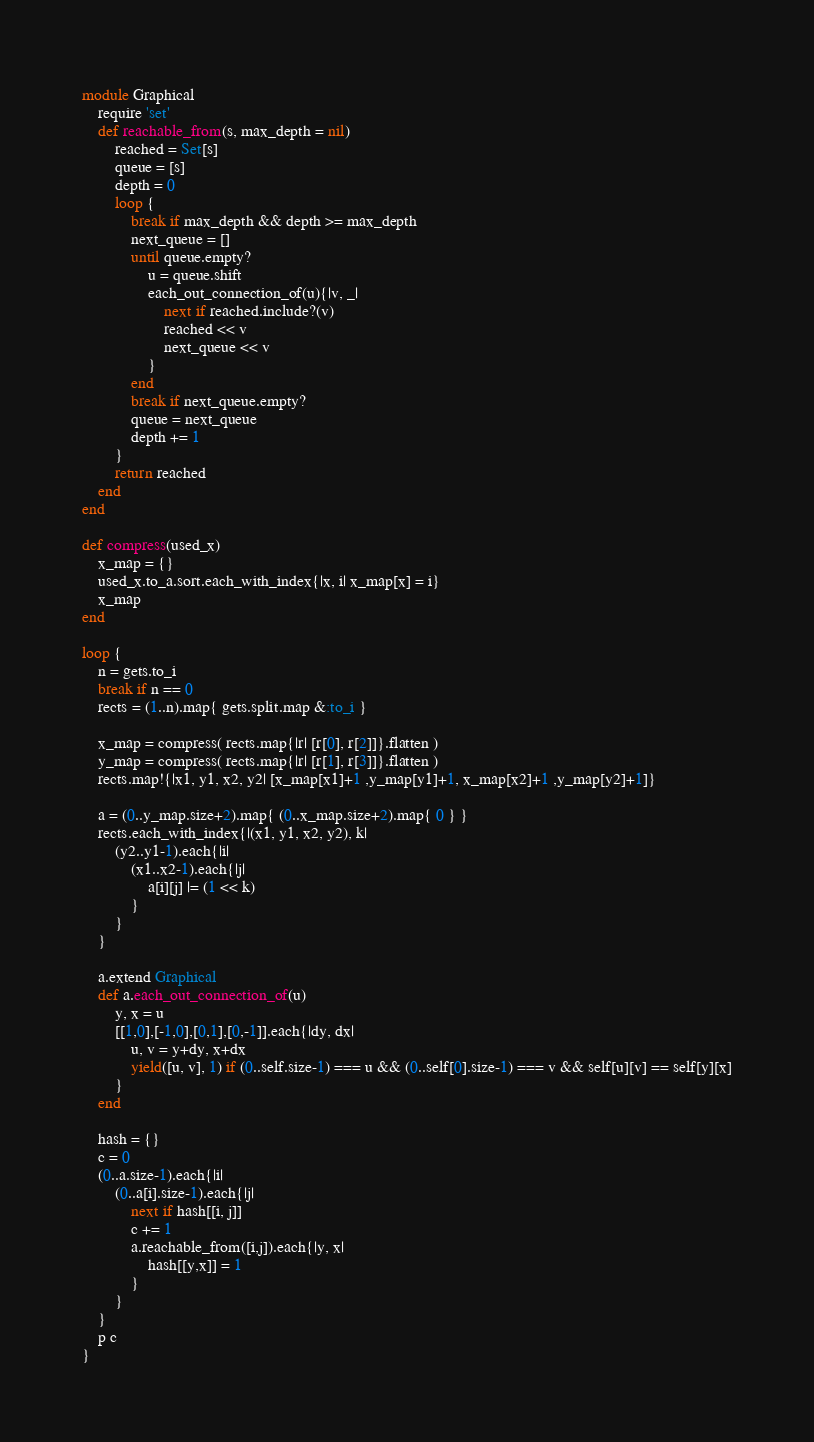Convert code to text. <code><loc_0><loc_0><loc_500><loc_500><_Ruby_>module Graphical
	require 'set'
	def reachable_from(s, max_depth = nil)
		reached = Set[s]
		queue = [s]
		depth = 0
		loop {
			break if max_depth && depth >= max_depth
			next_queue = []
			until queue.empty?
				u = queue.shift
				each_out_connection_of(u){|v, _|
					next if reached.include?(v)
					reached << v
					next_queue << v
				}
			end
			break if next_queue.empty?
			queue = next_queue
			depth += 1
		}
		return reached
	end
end

def compress(used_x)
	x_map = {}
	used_x.to_a.sort.each_with_index{|x, i| x_map[x] = i}
	x_map
end

loop {
	n = gets.to_i
	break if n == 0
	rects = (1..n).map{ gets.split.map &:to_i }

	x_map = compress( rects.map{|r| [r[0], r[2]]}.flatten )
	y_map = compress( rects.map{|r| [r[1], r[3]]}.flatten )
	rects.map!{|x1, y1, x2, y2| [x_map[x1]+1 ,y_map[y1]+1, x_map[x2]+1 ,y_map[y2]+1]}

	a = (0..y_map.size+2).map{ (0..x_map.size+2).map{ 0 } }
	rects.each_with_index{|(x1, y1, x2, y2), k| 
		(y2..y1-1).each{|i|
			(x1..x2-1).each{|j|
				a[i][j] |= (1 << k)
			}
		}
	}

	a.extend Graphical
	def a.each_out_connection_of(u)
		y, x = u
		[[1,0],[-1,0],[0,1],[0,-1]].each{|dy, dx|
			u, v = y+dy, x+dx	
			yield([u, v], 1) if (0..self.size-1) === u && (0..self[0].size-1) === v && self[u][v] == self[y][x]
		}
	end

	hash = {}
	c = 0
	(0..a.size-1).each{|i|
		(0..a[i].size-1).each{|j|
			next if hash[[i, j]]	
			c += 1
			a.reachable_from([i,j]).each{|y, x|
				hash[[y,x]] = 1
			}
		}
	}
	p c
}</code> 